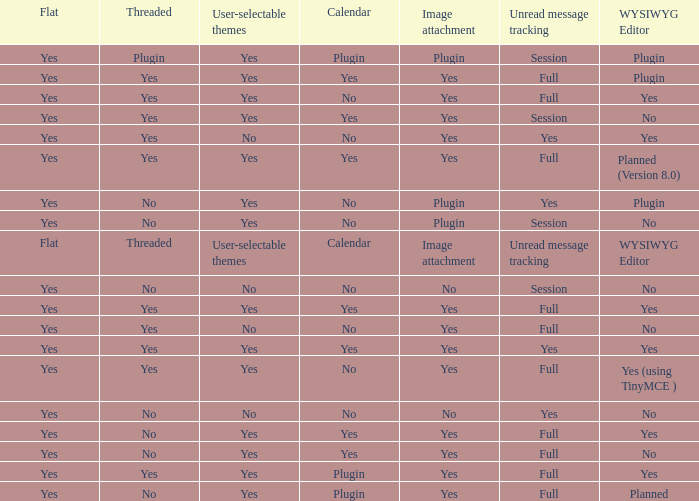Which Calendar has a User-selectable themes of user-selectable themes? Calendar. 